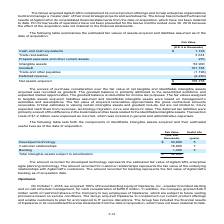According to Atlassian Plc's financial document, What does the amount recorded for developed technology represent? The estimated fair value of AgileCraft’s enterprise agile planning technology. The document states: "ount recorded for developed technology represents the estimated fair value of AgileCraft’s enterprise agile planning technology. The amount recorded f..." Also, What does the amount recorded for customer relationships represent? The fair value of the underlying relationships with AgileCraft’s customers.. The document states: "unt recorded for customer relationships represents the fair value of the underlying relationships with AgileCraft’s customers. The amount recorded for..." Also, What is the useful life of  Developed technology in years? According to the financial document, 5. The relevant text states: "Intangible assets 52,900..." Also, can you calculate: What is the difference in fair value between developed technology and customer relationships? Based on the calculation: 34,600-16,900, the result is 17700 (in thousands). This is based on the information: "Customer relationships 16,900 7 Developed technology $ 34,600 5..." The key data points involved are: 16,900, 34,600. Additionally, What are the identifiable intangible assets with a useful life above 5 years? Customer relationships. The document states: "Customer relationships 16,900 7..." Also, can you calculate: For fair value, what is the percentage constitution of customer relationships among the total intangible assets subject to amortization? Based on the calculation: 16,900/52,900, the result is 31.95 (percentage). This is based on the information: "Customer relationships 16,900 7 Intangible assets 52,900..." The key data points involved are: 16,900, 52,900. 